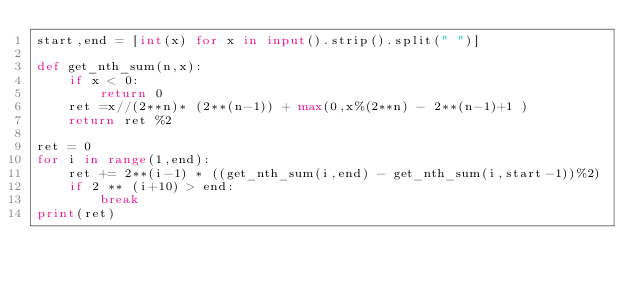<code> <loc_0><loc_0><loc_500><loc_500><_Python_>start,end = [int(x) for x in input().strip().split(" ")]

def get_nth_sum(n,x):
    if x < 0:
        return 0
    ret =x//(2**n)* (2**(n-1)) + max(0,x%(2**n) - 2**(n-1)+1 ) 
    return ret %2

ret = 0
for i in range(1,end):
    ret += 2**(i-1) * ((get_nth_sum(i,end) - get_nth_sum(i,start-1))%2)
    if 2 ** (i+10) > end:
        break
print(ret) </code> 